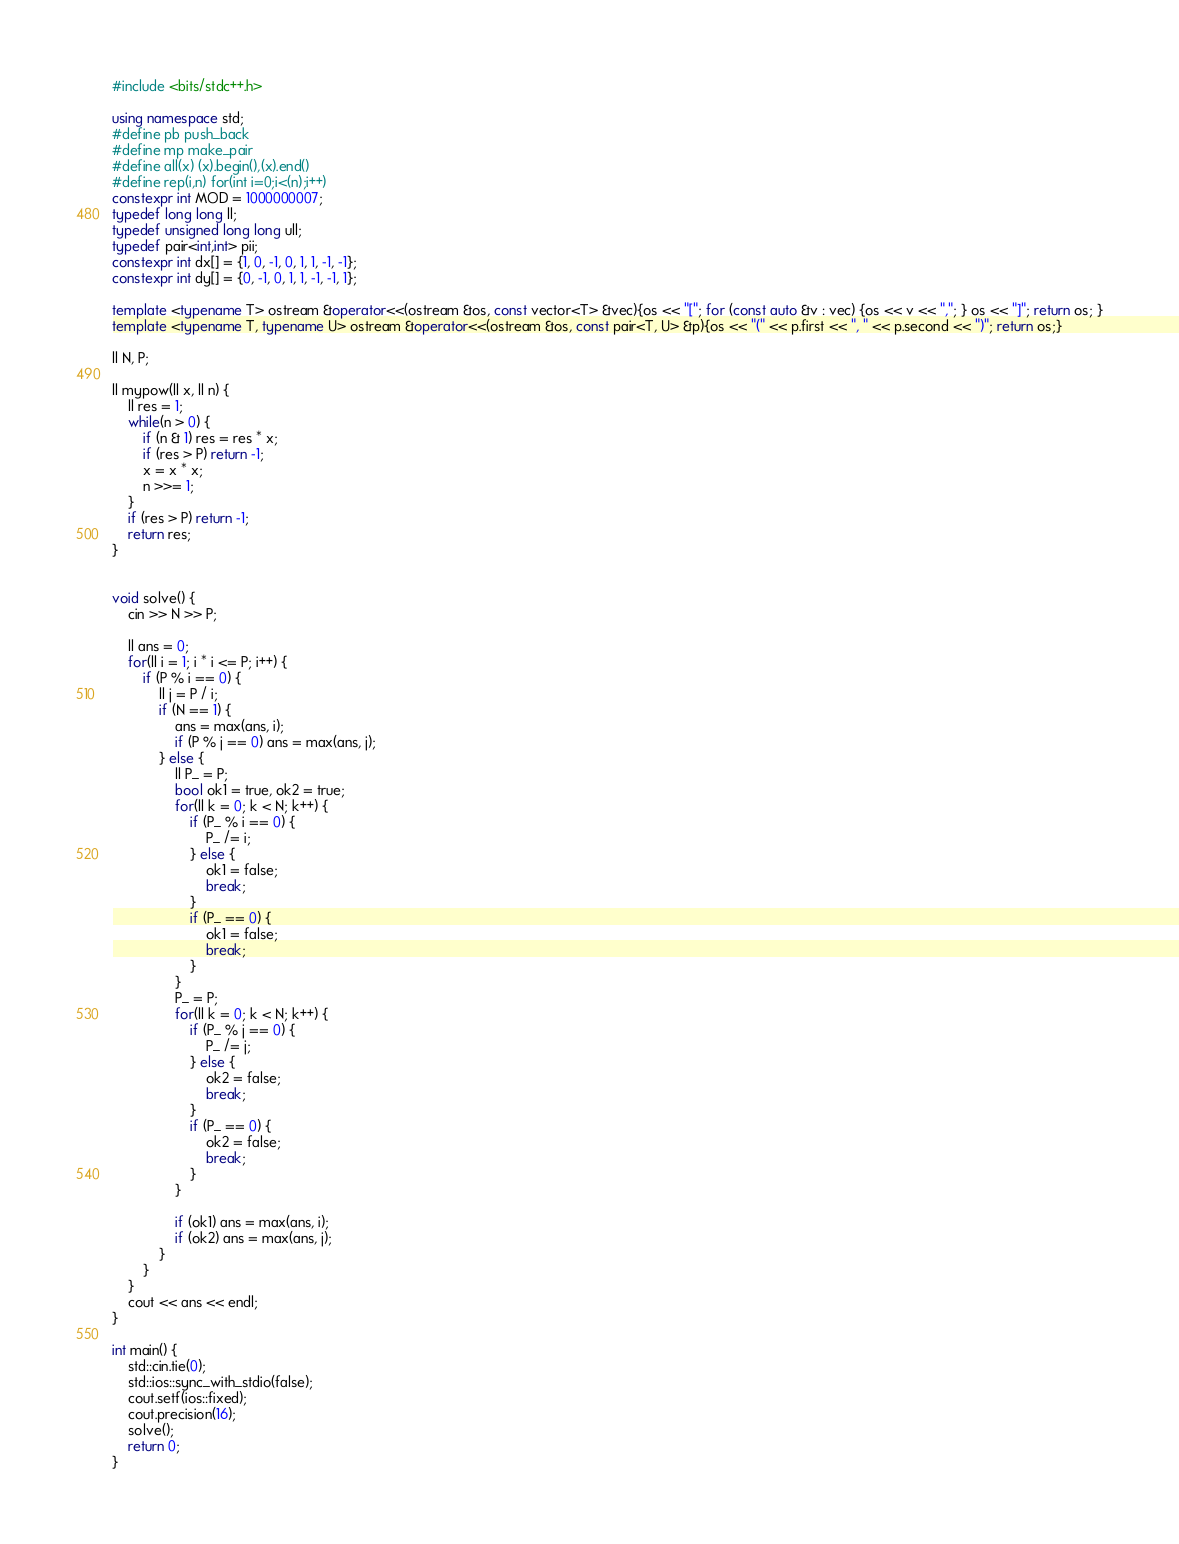<code> <loc_0><loc_0><loc_500><loc_500><_C++_>#include <bits/stdc++.h>

using namespace std;
#define pb push_back
#define mp make_pair
#define all(x) (x).begin(),(x).end()
#define rep(i,n) for(int i=0;i<(n);i++)
constexpr int MOD = 1000000007;
typedef long long ll;
typedef unsigned long long ull;
typedef pair<int,int> pii;
constexpr int dx[] = {1, 0, -1, 0, 1, 1, -1, -1};
constexpr int dy[] = {0, -1, 0, 1, 1, -1, -1, 1};

template <typename T> ostream &operator<<(ostream &os, const vector<T> &vec){os << "["; for (const auto &v : vec) {os << v << ","; } os << "]"; return os; }
template <typename T, typename U> ostream &operator<<(ostream &os, const pair<T, U> &p){os << "(" << p.first << ", " << p.second << ")"; return os;}

ll N, P;

ll mypow(ll x, ll n) {
    ll res = 1;
    while(n > 0) {
        if (n & 1) res = res * x;
        if (res > P) return -1;
        x = x * x;
        n >>= 1;
    }
    if (res > P) return -1;
    return res;
}


void solve() {
    cin >> N >> P;

    ll ans = 0;
    for(ll i = 1; i * i <= P; i++) {
        if (P % i == 0) {
            ll j = P / i;
            if (N == 1) {
                ans = max(ans, i);
                if (P % j == 0) ans = max(ans, j);
            } else {
                ll P_ = P;
                bool ok1 = true, ok2 = true;
                for(ll k = 0; k < N; k++) {
                    if (P_ % i == 0) {
                        P_ /= i;
                    } else {
                        ok1 = false;
                        break;
                    }
                    if (P_ == 0) {
                        ok1 = false;
                        break;
                    }
                }
                P_ = P;
                for(ll k = 0; k < N; k++) {
                    if (P_ % j == 0) {
                        P_ /= j;
                    } else {
                        ok2 = false;
                        break;
                    }
                    if (P_ == 0) {
                        ok2 = false;
                        break;
                    }
                }

                if (ok1) ans = max(ans, i);
                if (ok2) ans = max(ans, j);
            }
        }
    }
    cout << ans << endl;
}

int main() {
    std::cin.tie(0);
    std::ios::sync_with_stdio(false);
    cout.setf(ios::fixed);
    cout.precision(16);
    solve();
    return 0;
}</code> 